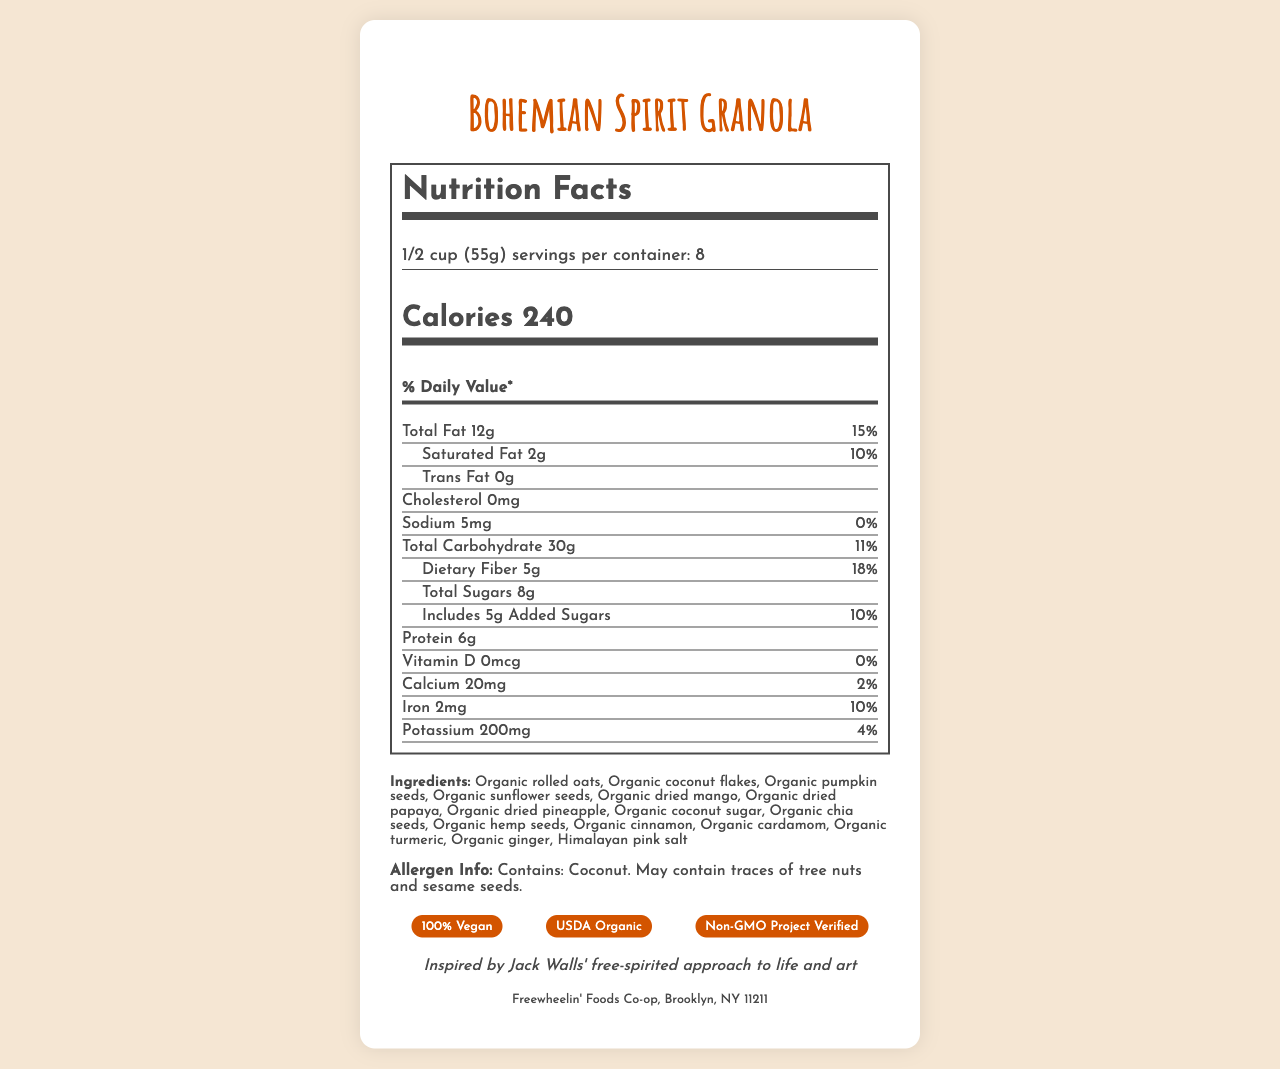what is the serving size? The serving size information is clearly stated as "1/2 cup (55g)" in the document.
Answer: 1/2 cup (55g) how many calories are in one serving of the granola? The calorie count per serving is listed as "240" in the document.
Answer: 240 what is the total amount of fat in one serving? The total amount of fat is listed as "12g" under the Nutrition Facts.
Answer: 12g how many grams of dietary fiber does one serving contain? The dietary fiber content per serving is listed as "5g" in the nutrient details.
Answer: 5g which of the following ingredients are included in the granola? A. Organic rolled oats B. Organic almonds C. Organic chia seeds D. Organic honey The ingredients include "Organic rolled oats" and "Organic chia seeds" but do not list "Organic almonds" or "Organic honey".
Answer: A, C what is the daily value percentage for iron in one serving? The daily value percentage for iron is listed as "10%" in the Nutrition Facts.
Answer: 10% how many servings are in one container? The document states that there are "8" servings per container.
Answer: 8 does the granola contain any cholesterol? The cholesterol content is listed as "0mg," indicating that it contains no cholesterol.
Answer: No how much calcium does one serving contain? A. 0mg B. 20mg C. 2mg D. 200mg The Nutrition Facts list the calcium content as "20mg" per serving.
Answer: B. 20mg describe the allergen information provided The allergen information states that the product contains coconut and may contain traces of tree nuts and sesame seeds.
Answer: Contains: Coconut. May contain traces of tree nuts and sesame seeds. what is the amount of added sugars in one serving? The document lists "Includes 5g Added Sugars" under the nutrient details.
Answer: 5g how much vitamin D is in one serving? The vitamin D content is listed as "0mcg" in the Nutrition Facts.
Answer: 0mcg what are the claims made about the granola? The document lists these claims under the "claims" section.
Answer: 100% Vegan, USDA Organic, Non-GMO Project Verified, Fair Trade Certified ingredients what type of packaging is used for the granola? The packaging is described as an "Eco-friendly, compostable bag."
Answer: Eco-friendly, compostable bag who is the manufacturer of Bohemian Spirit Granola? The manufacturer is stated at the end of the document.
Answer: Freewheelin' Foods Co-op, Brooklyn, NY 11211 what is the main inspiration behind the granola? The document mentions that the granola was inspired by Jack Walls' free-spirited approach to life and art.
Answer: Inspired by Jack Walls' free-spirited approach to life and art describe the design of the packaging The artistic touch is described as having a unique, hand-drawn mandala design on each bag.
Answer: Each bag features a unique, hand-drawn mandala design is this granola gluten-free? The document does not provide any information about the granola being gluten-free.
Answer: Not enough information summarize the main idea of this document The document summarizes essential details about the granola, including its nutritional content, ingredient list, allergen warning, and different claims. It also highlights the artistic inspiration behind the product and describes the unique packaging.
Answer: The document provides detailed nutrition facts, ingredient list, allergen information, and various claims for Bohemian Spirit Granola, a product featuring a free-spirited and artistic design inspired by Jack Walls. The granola is made with organic and vegan ingredients and comes in eco-friendly packaging. 